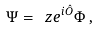Convert formula to latex. <formula><loc_0><loc_0><loc_500><loc_500>\Psi = \ z e ^ { i \hat { O } } \Phi \, ,</formula> 